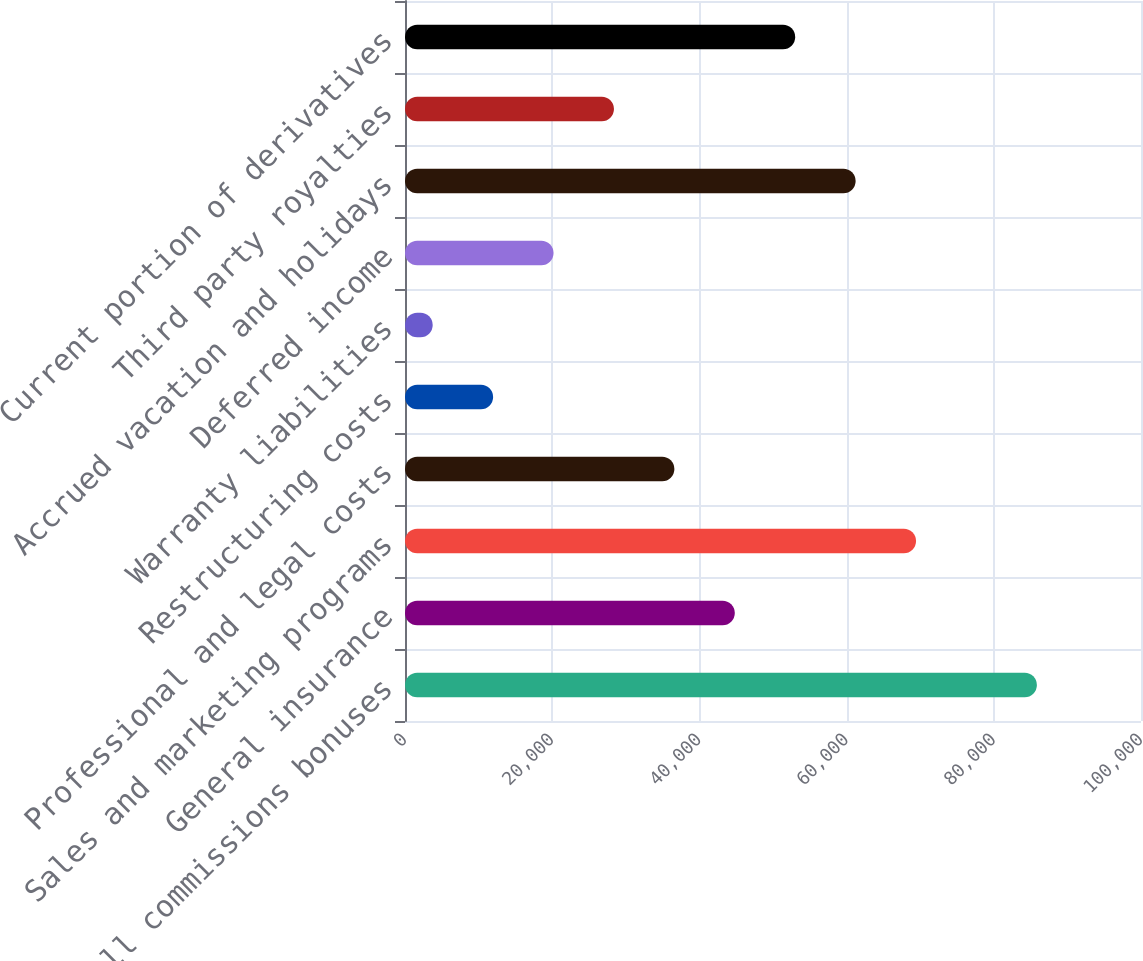Convert chart to OTSL. <chart><loc_0><loc_0><loc_500><loc_500><bar_chart><fcel>Payroll commissions bonuses<fcel>General insurance<fcel>Sales and marketing programs<fcel>Professional and legal costs<fcel>Restructuring costs<fcel>Warranty liabilities<fcel>Deferred income<fcel>Accrued vacation and holidays<fcel>Third party royalties<fcel>Current portion of derivatives<nl><fcel>85855<fcel>44810<fcel>69437<fcel>36601<fcel>11974<fcel>3765<fcel>20183<fcel>61228<fcel>28392<fcel>53019<nl></chart> 